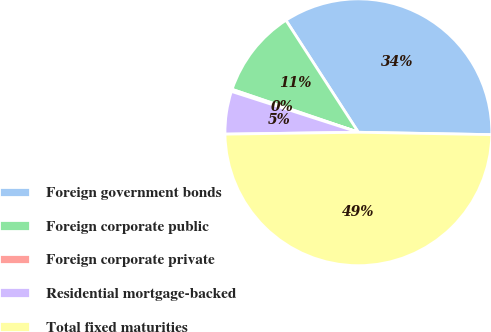Convert chart to OTSL. <chart><loc_0><loc_0><loc_500><loc_500><pie_chart><fcel>Foreign government bonds<fcel>Foreign corporate public<fcel>Foreign corporate private<fcel>Residential mortgage-backed<fcel>Total fixed maturities<nl><fcel>34.42%<fcel>10.65%<fcel>0.26%<fcel>5.18%<fcel>49.49%<nl></chart> 